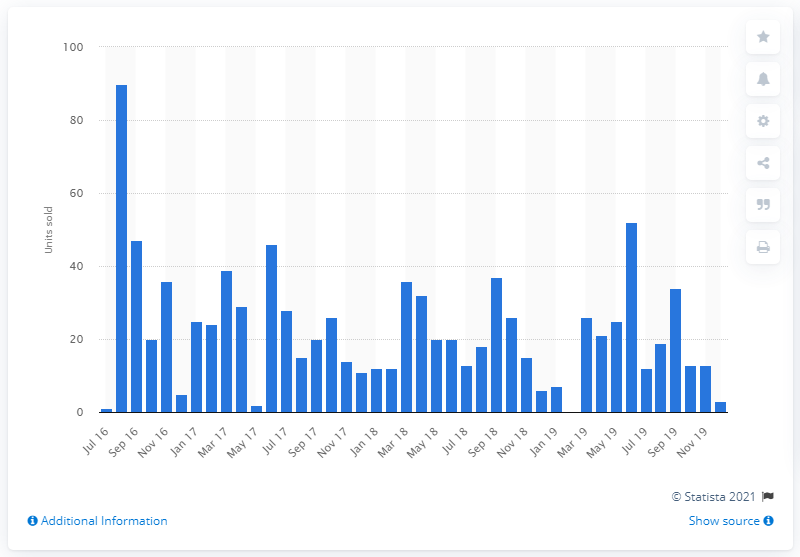Give some essential details in this illustration. In June 2019, 52 new Lotus units were sold. In August 2016, a total of 90 Lotus cars were sold in the UK. 